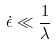<formula> <loc_0><loc_0><loc_500><loc_500>\dot { \epsilon } \ll \frac { 1 } { \lambda }</formula> 